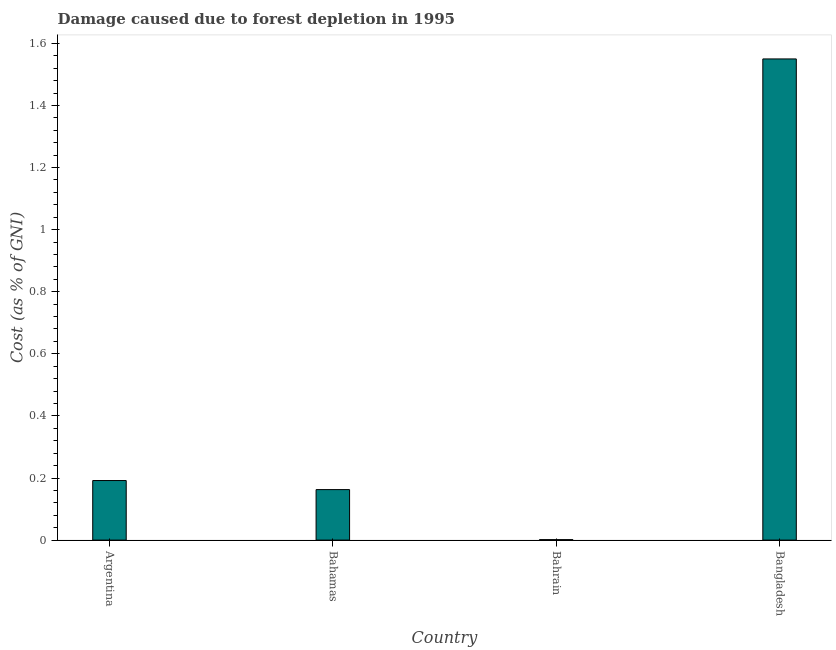Does the graph contain any zero values?
Offer a very short reply. No. What is the title of the graph?
Offer a very short reply. Damage caused due to forest depletion in 1995. What is the label or title of the Y-axis?
Your answer should be very brief. Cost (as % of GNI). What is the damage caused due to forest depletion in Bahrain?
Ensure brevity in your answer.  0. Across all countries, what is the maximum damage caused due to forest depletion?
Provide a short and direct response. 1.55. Across all countries, what is the minimum damage caused due to forest depletion?
Offer a terse response. 0. In which country was the damage caused due to forest depletion minimum?
Keep it short and to the point. Bahrain. What is the sum of the damage caused due to forest depletion?
Provide a short and direct response. 1.91. What is the difference between the damage caused due to forest depletion in Argentina and Bahamas?
Your response must be concise. 0.03. What is the average damage caused due to forest depletion per country?
Keep it short and to the point. 0.48. What is the median damage caused due to forest depletion?
Ensure brevity in your answer.  0.18. In how many countries, is the damage caused due to forest depletion greater than 0.12 %?
Make the answer very short. 3. What is the ratio of the damage caused due to forest depletion in Argentina to that in Bangladesh?
Offer a very short reply. 0.12. What is the difference between the highest and the second highest damage caused due to forest depletion?
Provide a succinct answer. 1.36. What is the difference between the highest and the lowest damage caused due to forest depletion?
Your answer should be very brief. 1.55. How many bars are there?
Your answer should be compact. 4. Are all the bars in the graph horizontal?
Provide a short and direct response. No. How many countries are there in the graph?
Offer a terse response. 4. What is the Cost (as % of GNI) of Argentina?
Provide a short and direct response. 0.19. What is the Cost (as % of GNI) in Bahamas?
Provide a succinct answer. 0.16. What is the Cost (as % of GNI) of Bahrain?
Make the answer very short. 0. What is the Cost (as % of GNI) of Bangladesh?
Provide a short and direct response. 1.55. What is the difference between the Cost (as % of GNI) in Argentina and Bahamas?
Your answer should be very brief. 0.03. What is the difference between the Cost (as % of GNI) in Argentina and Bahrain?
Offer a very short reply. 0.19. What is the difference between the Cost (as % of GNI) in Argentina and Bangladesh?
Provide a succinct answer. -1.36. What is the difference between the Cost (as % of GNI) in Bahamas and Bahrain?
Your response must be concise. 0.16. What is the difference between the Cost (as % of GNI) in Bahamas and Bangladesh?
Offer a very short reply. -1.39. What is the difference between the Cost (as % of GNI) in Bahrain and Bangladesh?
Your response must be concise. -1.55. What is the ratio of the Cost (as % of GNI) in Argentina to that in Bahamas?
Offer a very short reply. 1.18. What is the ratio of the Cost (as % of GNI) in Argentina to that in Bahrain?
Your answer should be very brief. 133.01. What is the ratio of the Cost (as % of GNI) in Argentina to that in Bangladesh?
Give a very brief answer. 0.12. What is the ratio of the Cost (as % of GNI) in Bahamas to that in Bahrain?
Give a very brief answer. 112.79. What is the ratio of the Cost (as % of GNI) in Bahamas to that in Bangladesh?
Keep it short and to the point. 0.1. What is the ratio of the Cost (as % of GNI) in Bahrain to that in Bangladesh?
Your answer should be very brief. 0. 